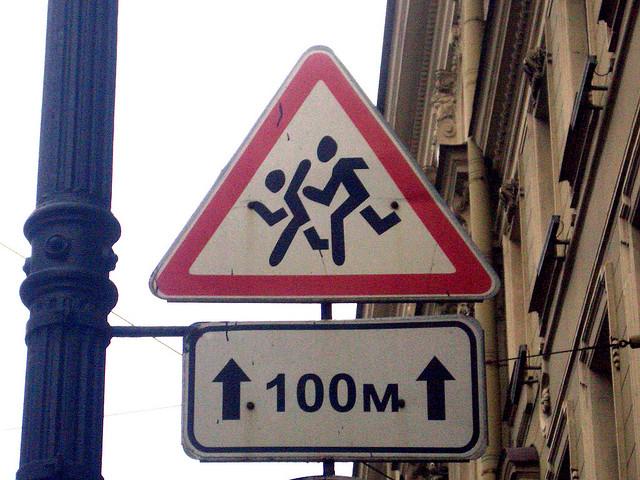Is this a yield sign?
Be succinct. Yes. What color is the sign?
Short answer required. White. What number is on the sign?
Keep it brief. 100. What is the boy chasing on this sign?
Concise answer only. Another boy. Could the figures be running?
Give a very brief answer. Yes. Which way are the arrows pointing?
Be succinct. Up. Is there any sign board?
Answer briefly. Yes. What color is the letters written on the signs?
Be succinct. Black. What business is on the building?
Answer briefly. Bank. What language are the bottom letters written in?
Concise answer only. English. Is the destination 100m away?
Write a very short answer. Yes. 